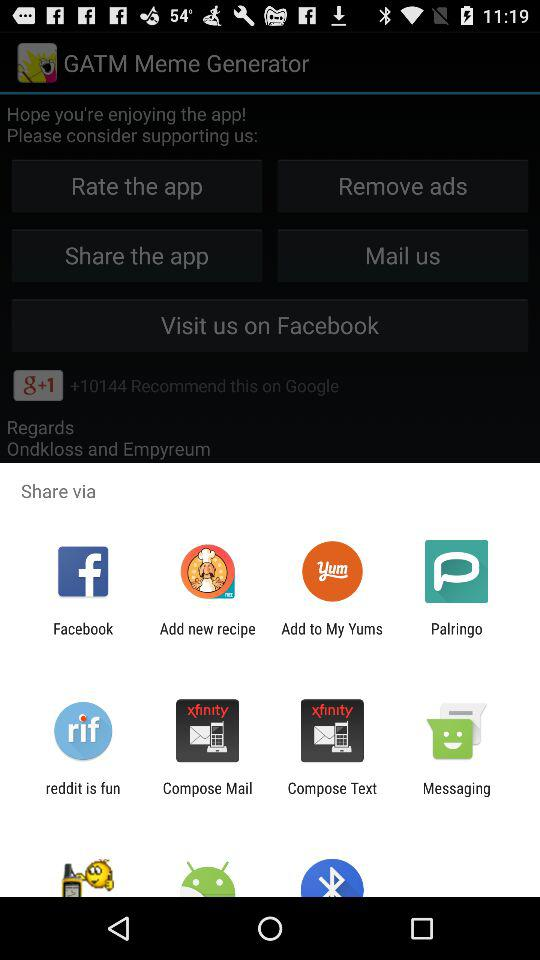What applications can be used to share? The applications that can be used to share are "Facebook", "Add new recipe", "Add to My Yums", "Palringo", "reddit is fun", "Compose Mail", "Compose Text" and "Messaging". 